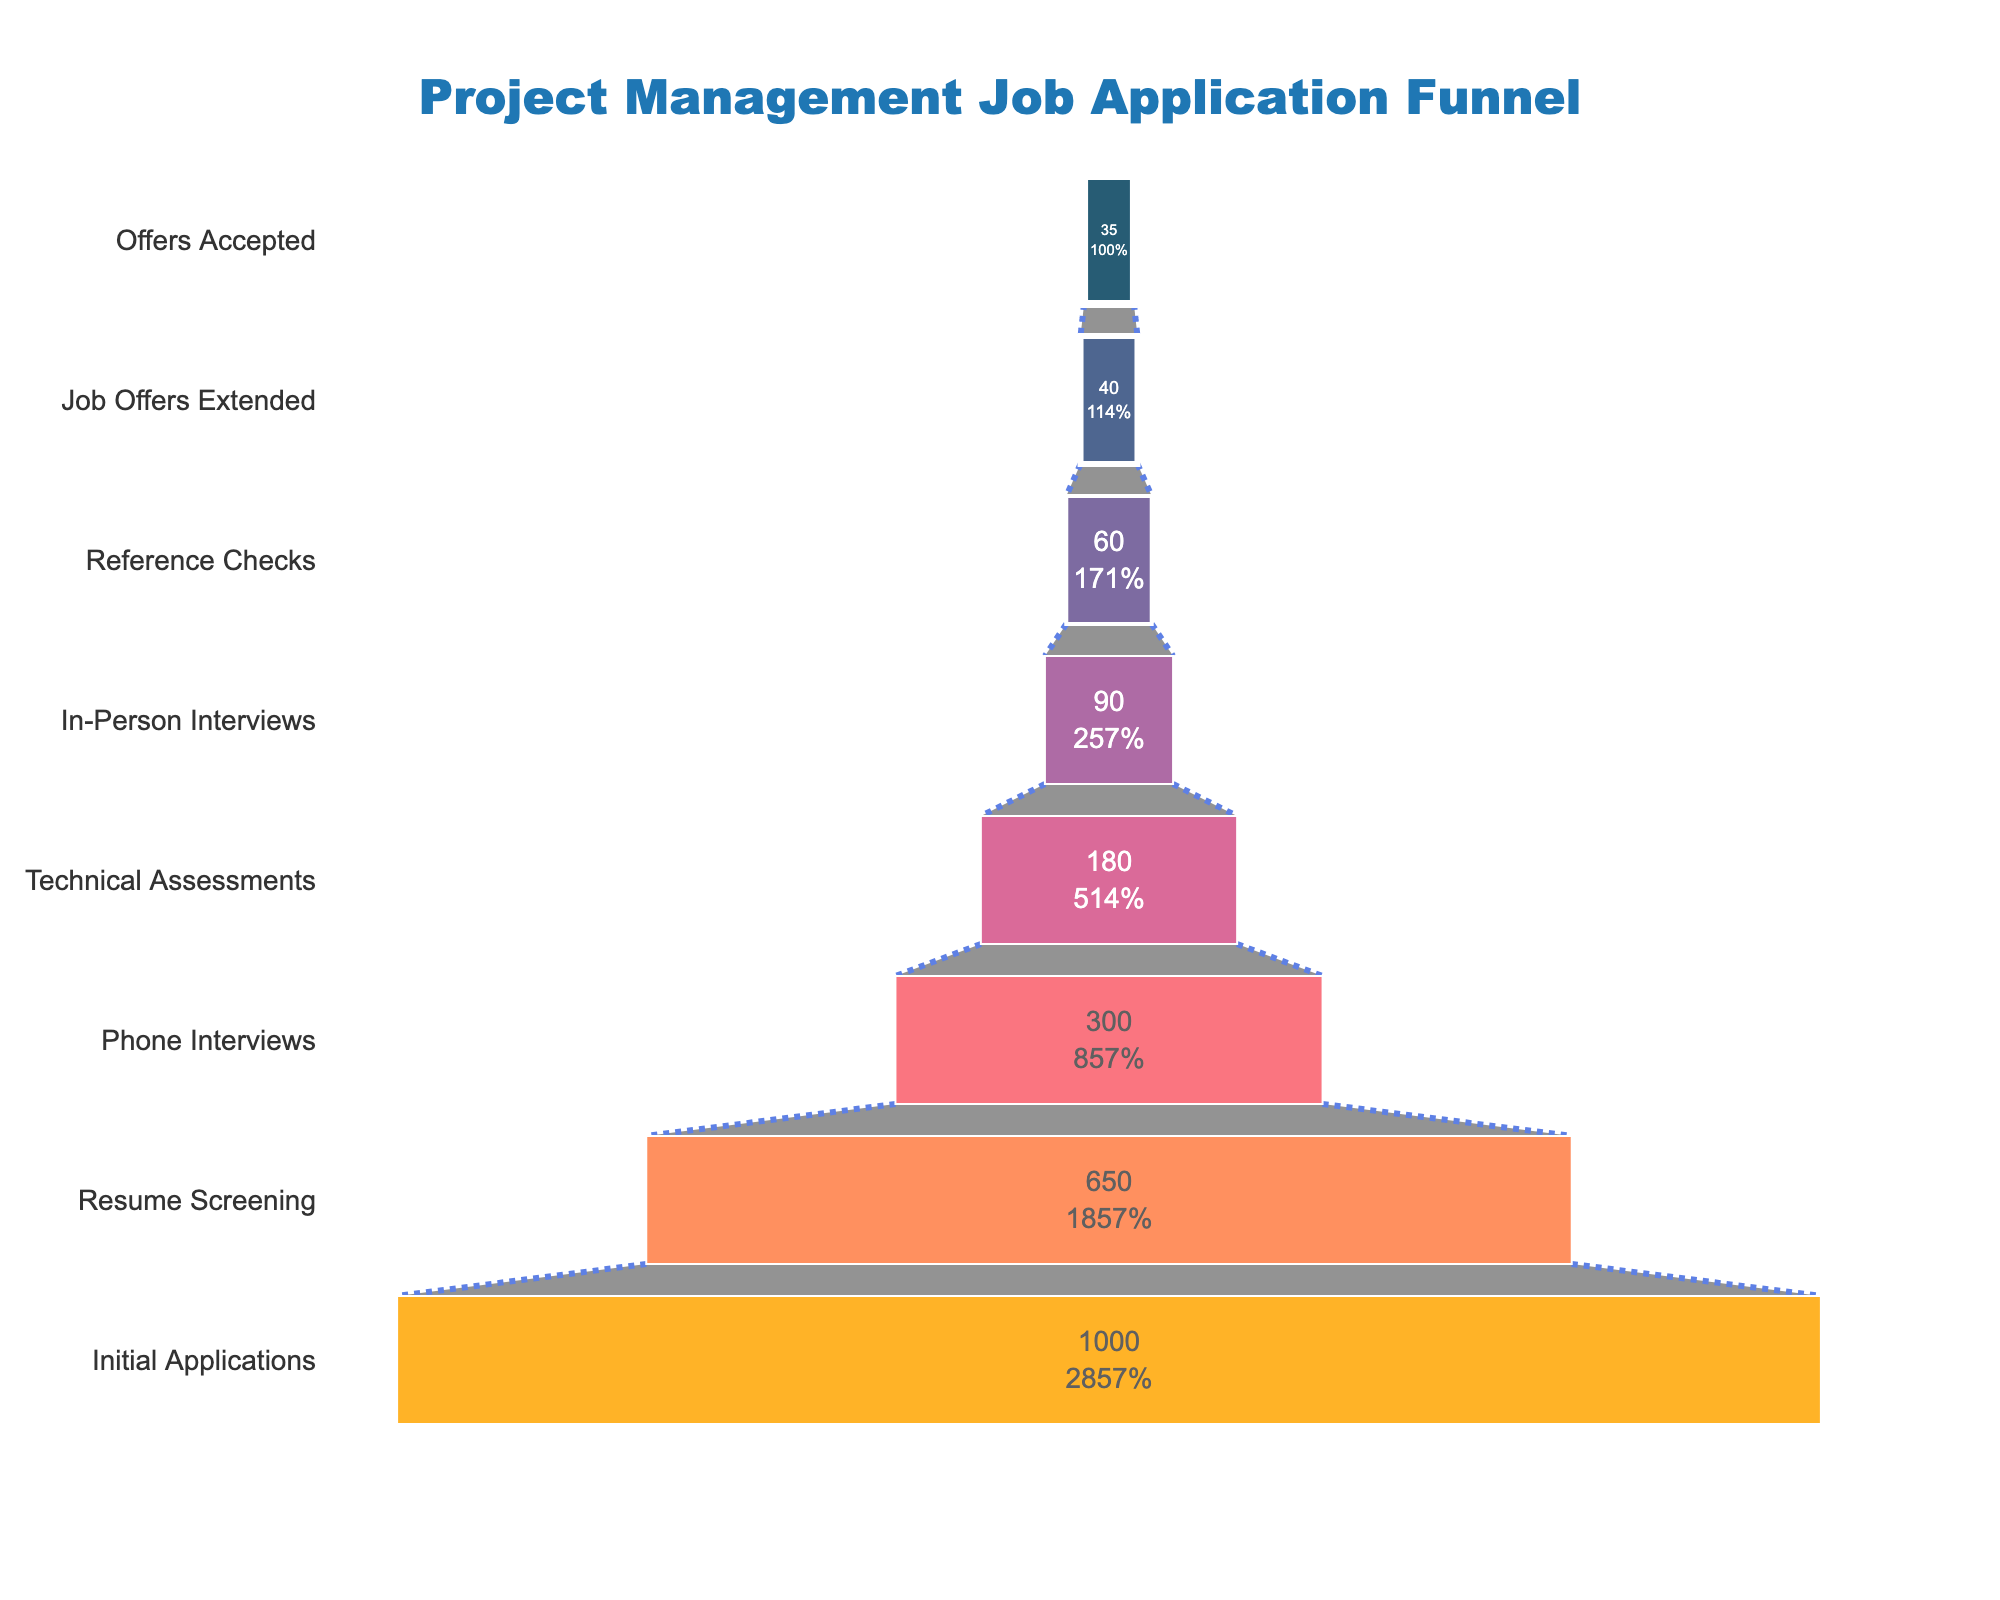What's the title of the funnel chart? The title is positioned at the top center of the funnel chart. It is labeled with a specific font and color to make it stand out.
Answer: Project Management Job Application Funnel How many stages are represented in the funnel chart? The funnel chart represents each stage visually from the top to the bottom in a descending order according to the data provided. Count the number of stages.
Answer: 8 Which stage has the highest number of applicants and how many? Look at the topmost segment of the funnel chart which represents the initial stage. Note the number of applicants in that segment.
Answer: Initial Applications, 1000 What percentage of applicants move from Phone Interviews to Technical Assessments? Check the value and the percentage of applicants at the Phone Interviews stage and compare it to the value at Technical Assessments. Calculate (180/300)*100%.
Answer: 60% How many applicants accepted the job offers? Check the bottommost segment of the funnel chart. This part corresponds to the final stage of the funnel.
Answer: 35 How many applicants did not move past the Resume Screening stage? Subtract the number of applicants that moved past the Resume Screening stage from the initial applicants. 1000 - 650 = 350
Answer: 350 From which stage to which stage did the number of applicants halve for the first time? Compare the number of applicants between successive stages until you find the first instance where the number of applicants is roughly half of the previous stage. 650 for Resume Screening and 300 for Phone Interviews.
Answer: Resume Screening to Phone Interviews What is the difference between the number of applicants in the Technical Assessments and In-Person Interviews stages? Subtract the number of applicants in the In-Person Interviews from the number in Technical Assessments. 180 - 90 = 90
Answer: 90 Are there any stages where the drop-off rate is 50% or more? Identify stages where the drop in the number of applicants from one stage to the next is 50% or more. (1000 to 650, 650 to 300, and others). Check percentages of reduction.
Answer: Yes What is the total percentage of applicants that actually accepted the job offers out of the initial applications? Calculate the percentage of applicants who accepted job offers out of the initial applicants. (35/1000)*100 = 3.5%
Answer: 3.5% 